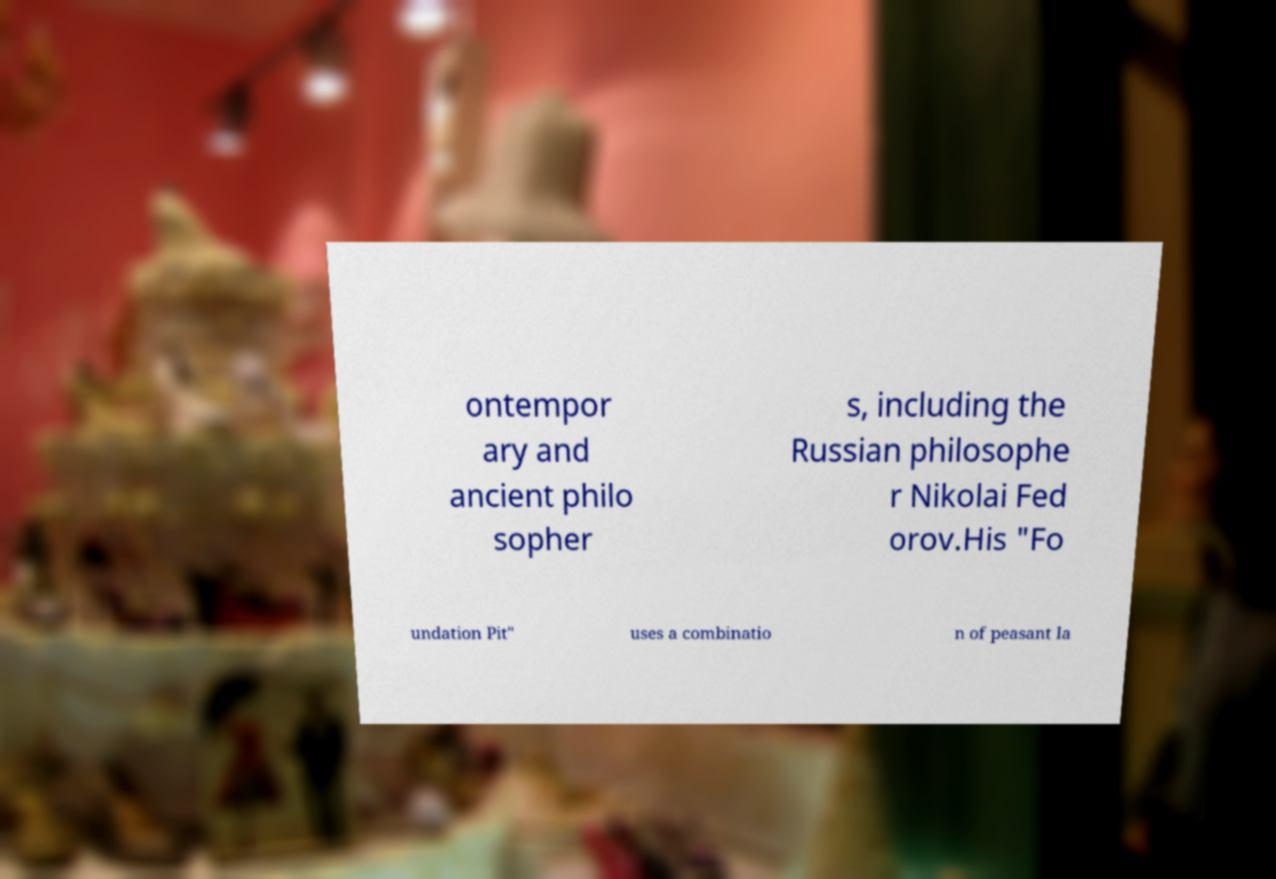Could you assist in decoding the text presented in this image and type it out clearly? ontempor ary and ancient philo sopher s, including the Russian philosophe r Nikolai Fed orov.His "Fo undation Pit" uses a combinatio n of peasant la 